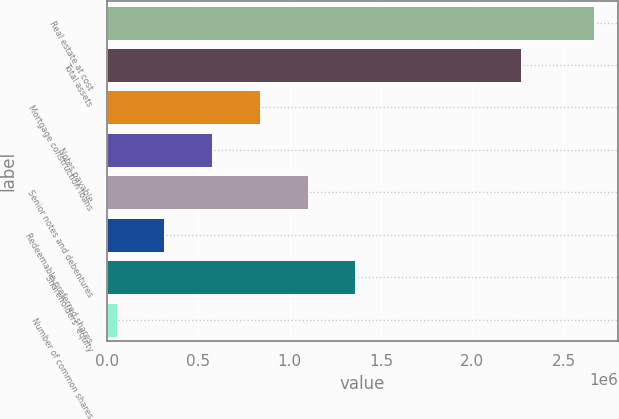<chart> <loc_0><loc_0><loc_500><loc_500><bar_chart><fcel>Real estate at cost<fcel>Total assets<fcel>Mortgage construction loans<fcel>Notes payable<fcel>Senior notes and debentures<fcel>Redeemable preferred shares<fcel>Shareholders' equity<fcel>Number of common shares<nl><fcel>2.66628e+06<fcel>2.2669e+06<fcel>836379<fcel>574965<fcel>1.09779e+06<fcel>313551<fcel>1.35921e+06<fcel>52137<nl></chart> 